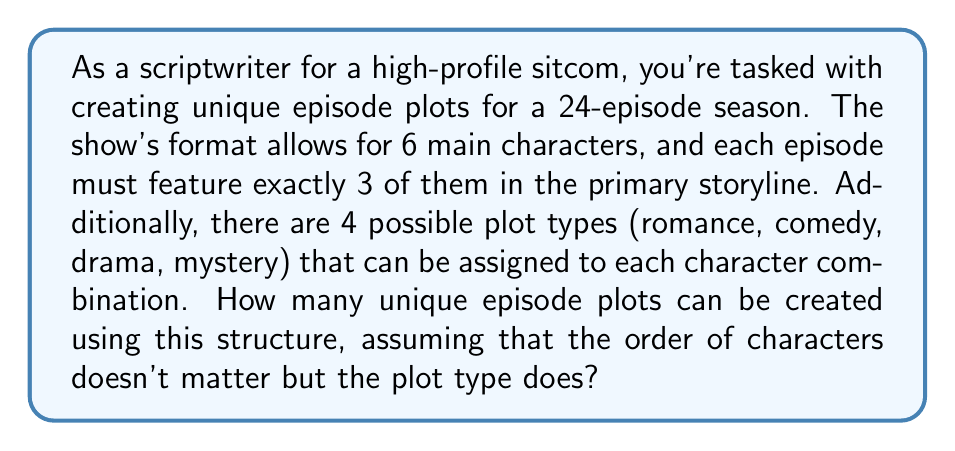Show me your answer to this math problem. To solve this problem, we'll use a combination of group theory and combinatorics. Let's break it down step by step:

1. First, we need to calculate the number of ways to choose 3 characters out of 6. This is a combination problem, denoted as $\binom{6}{3}$. The formula for this combination is:

   $$\binom{6}{3} = \frac{6!}{3!(6-3)!} = \frac{6!}{3!3!} = 20$$

2. Now, for each of these 20 character combinations, we have 4 possible plot types. This is where we use the multiplication principle from combinatorics. The total number of unique plots is the product of the number of character combinations and the number of plot types:

   $$20 \times 4 = 80$$

3. However, we need to consider the symmetry of the character combinations. The group theory aspect comes into play here. The group of permutations of 3 characters is isomorphic to the symmetric group $S_3$, which has 6 elements (3! = 6). This means that each unique combination of 3 characters can be arranged in 6 different ways, but we consider these arrangements equivalent for our purposes.

4. To account for this symmetry, we need to divide our total by the order of the symmetry group:

   $$\frac{80}{6} = \frac{40}{3} = 13\frac{1}{3}$$

5. Since we can't have a fractional number of episode plots, we round down to the nearest whole number.

Therefore, the number of unique episode plots that can be created is 13.
Answer: 13 unique episode plots 